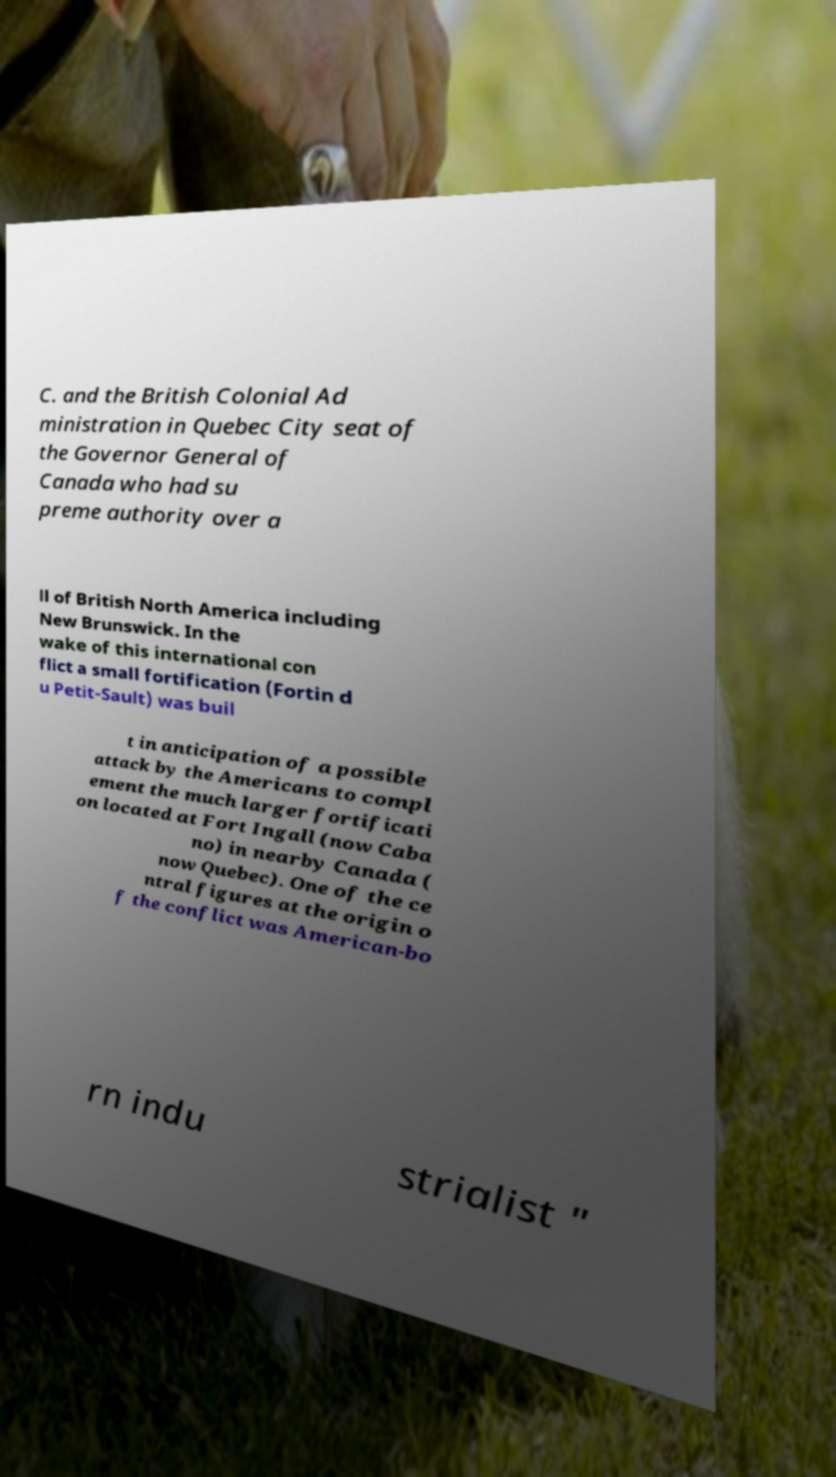Can you read and provide the text displayed in the image?This photo seems to have some interesting text. Can you extract and type it out for me? C. and the British Colonial Ad ministration in Quebec City seat of the Governor General of Canada who had su preme authority over a ll of British North America including New Brunswick. In the wake of this international con flict a small fortification (Fortin d u Petit-Sault) was buil t in anticipation of a possible attack by the Americans to compl ement the much larger fortificati on located at Fort Ingall (now Caba no) in nearby Canada ( now Quebec). One of the ce ntral figures at the origin o f the conflict was American-bo rn indu strialist " 